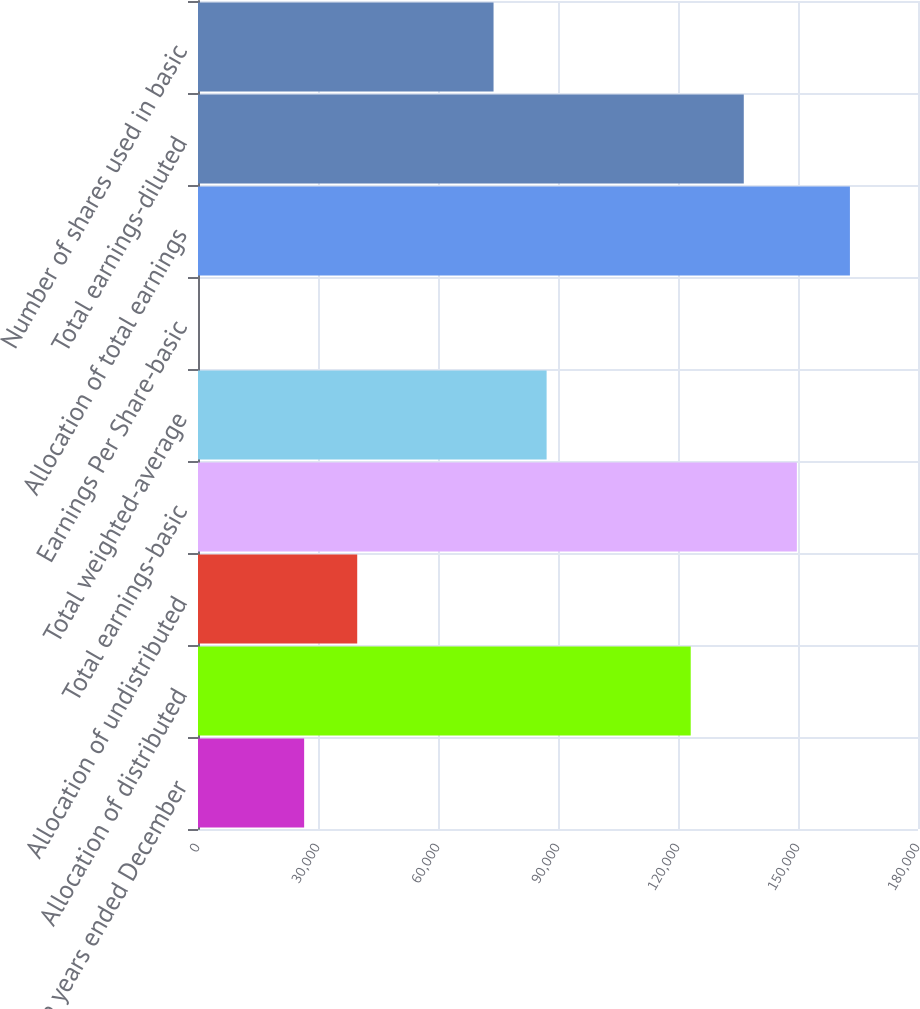<chart> <loc_0><loc_0><loc_500><loc_500><bar_chart><fcel>For the years ended December<fcel>Allocation of distributed<fcel>Allocation of undistributed<fcel>Total earnings-basic<fcel>Total weighted-average<fcel>Earnings Per Share-basic<fcel>Allocation of total earnings<fcel>Total earnings-diluted<fcel>Number of shares used in basic<nl><fcel>26536.5<fcel>123179<fcel>39803.7<fcel>149713<fcel>87154.4<fcel>2.19<fcel>162981<fcel>136446<fcel>73887.2<nl></chart> 